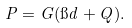<formula> <loc_0><loc_0><loc_500><loc_500>P = G ( \i d + Q ) .</formula> 